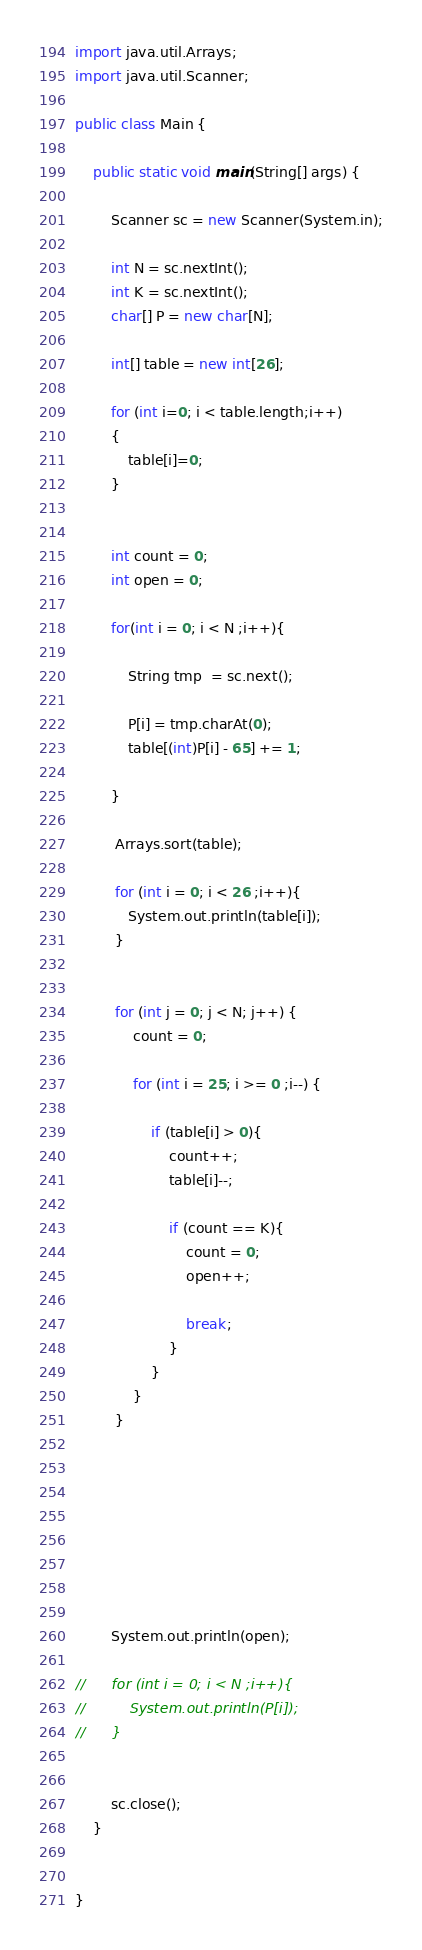<code> <loc_0><loc_0><loc_500><loc_500><_Java_>import java.util.Arrays;
import java.util.Scanner;

public class Main {

	public static void main(String[] args) {

		Scanner sc = new Scanner(System.in);

		int N = sc.nextInt();
		int K = sc.nextInt();
		char[] P = new char[N];

		int[] table = new int[26];

		for (int i=0; i < table.length;i++)
		{
			table[i]=0;
		}


		int count = 0;
		int open = 0;

		for(int i = 0; i < N ;i++){

			String tmp  = sc.next();

			P[i] = tmp.charAt(0);
			table[(int)P[i] - 65] += 1;

		}

		 Arrays.sort(table);

		 for (int i = 0; i < 26 ;i++){
			System.out.println(table[i]);
		 }


		 for (int j = 0; j < N; j++) {
			 count = 0;

			 for (int i = 25; i >= 0 ;i--) {

				 if (table[i] > 0){
					 count++;
					 table[i]--;

					 if (count == K){
						 count = 0;
						 open++;

						 break;
					 }
				 }
			 }
		 }








		System.out.println(open);

//		for (int i = 0; i < N ;i++){
//			System.out.println(P[i]);
//		}


		sc.close();
	}


}
</code> 